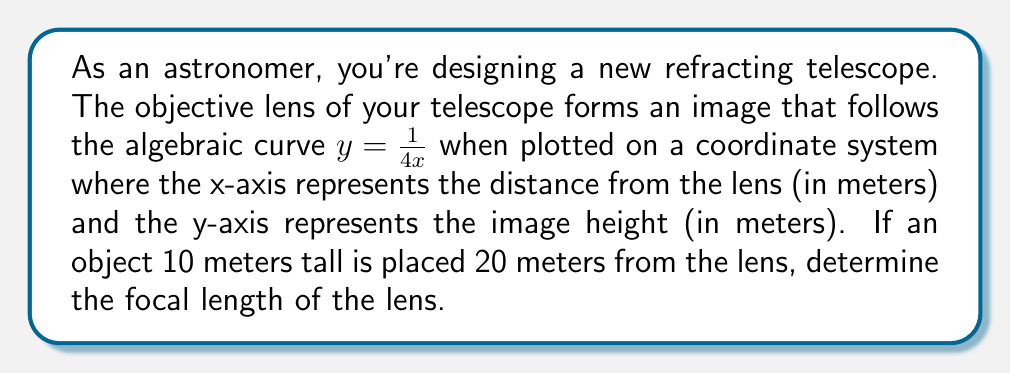Give your solution to this math problem. Let's approach this step-by-step:

1) The given algebraic curve is $y = \frac{1}{4x}$. This represents the relationship between the image distance (x) and the image height (y).

2) We know that for a thin lens, the relationship between object distance (u), image distance (v), and focal length (f) is given by the lens equation:

   $$\frac{1}{f} = \frac{1}{u} + \frac{1}{v}$$

3) We're also given that the object is 10 meters tall and placed 20 meters from the lens. So, u = 20 meters.

4) To find v (image distance), we need to use the magnification formula:

   $$M = \frac{image height}{object height} = \frac{v}{u}$$

5) We can find the image height by plugging v into our curve equation:

   $$y = \frac{1}{4v}$$

6) Now, let's set up the magnification equation:

   $$\frac{1}{4v} = \frac{v}{20}$$

7) Solving for v:

   $$20 = 4v^2$$
   $$v^2 = 5$$
   $$v = \sqrt{5} \approx 2.236 \text{ meters}$$

8) Now that we have u and v, we can use the lens equation to find f:

   $$\frac{1}{f} = \frac{1}{20} + \frac{1}{\sqrt{5}}$$

9) Solving for f:

   $$f = \frac{20\sqrt{5}}{20 + \sqrt{5}} \approx 1.951 \text{ meters}$$
Answer: $f = \frac{20\sqrt{5}}{20 + \sqrt{5}} \approx 1.951 \text{ meters}$ 